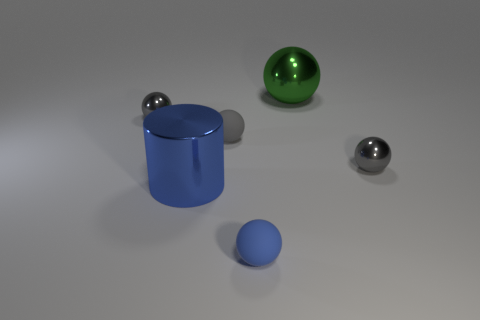How many gray balls must be subtracted to get 2 gray balls? 1 Subtract all gray cubes. How many gray balls are left? 3 Subtract 2 balls. How many balls are left? 3 Add 2 big blue objects. How many objects exist? 8 Subtract all cylinders. How many objects are left? 5 Subtract all cylinders. Subtract all green objects. How many objects are left? 4 Add 4 tiny objects. How many tiny objects are left? 8 Add 2 tiny metallic things. How many tiny metallic things exist? 4 Subtract 0 cyan cylinders. How many objects are left? 6 